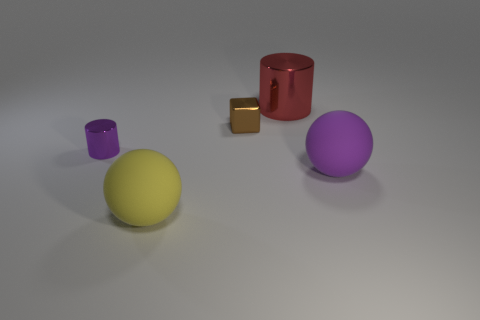What shape is the large object that is the same color as the tiny shiny cylinder?
Offer a terse response. Sphere. What shape is the small brown metallic object that is behind the big matte ball right of the brown thing?
Offer a terse response. Cube. Is there another big yellow object of the same shape as the yellow object?
Make the answer very short. No. The red thing that is the same size as the yellow object is what shape?
Ensure brevity in your answer.  Cylinder. There is a big sphere to the right of the big ball that is left of the large purple matte thing; is there a big purple rubber ball that is right of it?
Make the answer very short. No. Are there any yellow rubber spheres that have the same size as the yellow object?
Keep it short and to the point. No. What size is the cylinder that is right of the small brown block?
Offer a terse response. Large. What color is the shiny cylinder that is behind the tiny metal thing on the right side of the small metal thing in front of the tiny brown block?
Offer a very short reply. Red. There is a cylinder right of the purple thing that is left of the big red metallic cylinder; what is its color?
Make the answer very short. Red. Are there more metallic objects on the right side of the purple cylinder than matte things that are left of the big yellow matte ball?
Keep it short and to the point. Yes. 